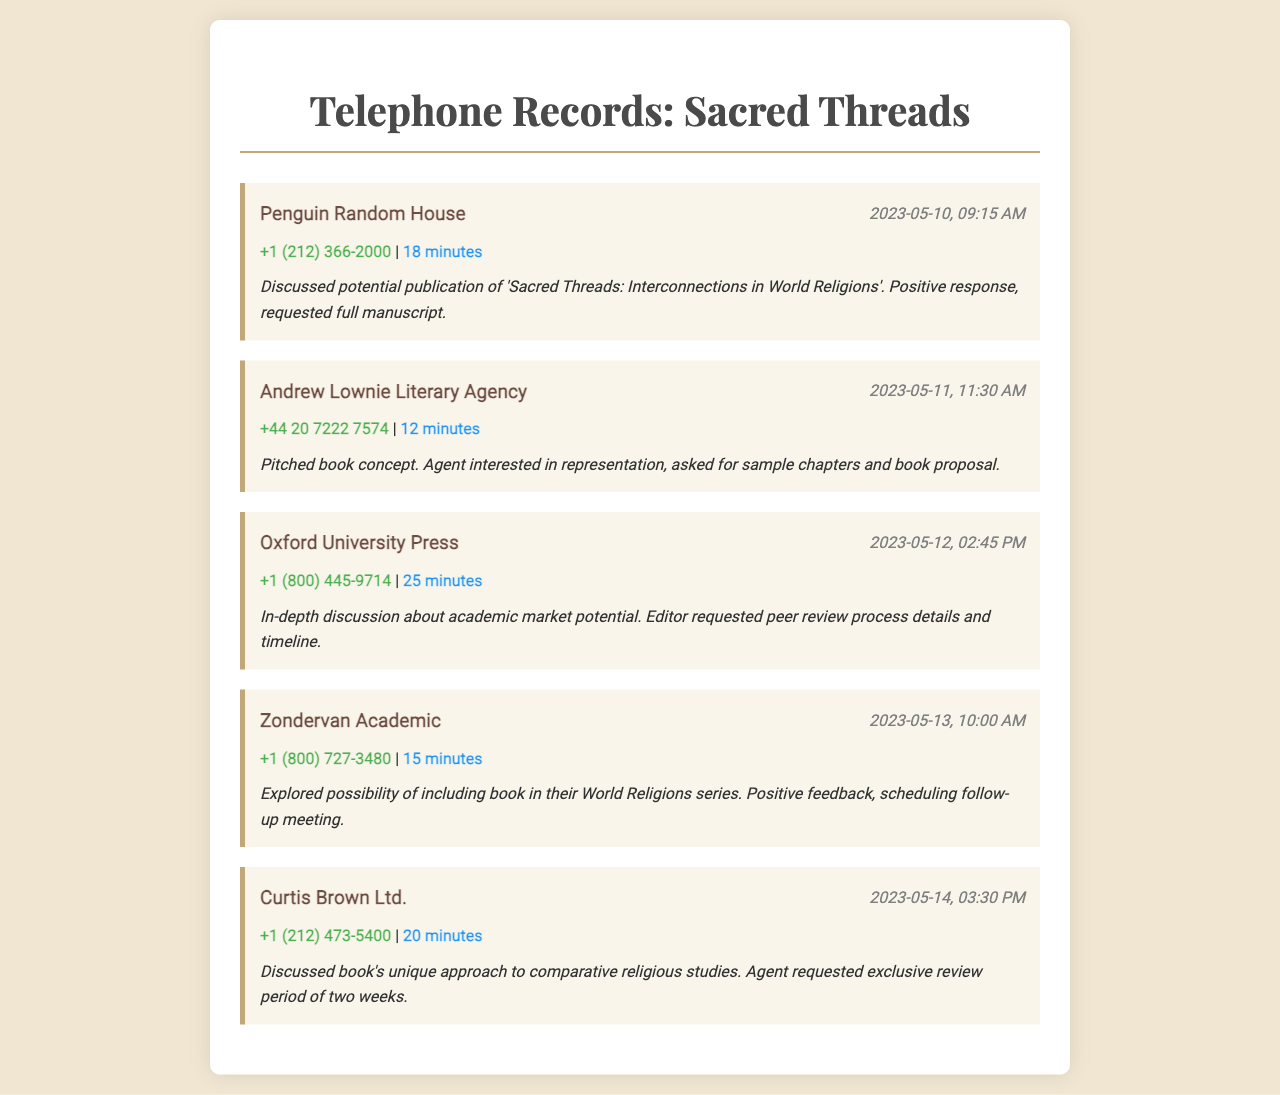What is the title of the book discussed? The title of the book is mentioned in the notes of the first record as 'Sacred Threads: Interconnections in World Religions'.
Answer: Sacred Threads: Interconnections in World Religions Who was contacted on May 12, 2023? The contact for May 12, 2023, was Oxford University Press as indicated in the date-time of the third record.
Answer: Oxford University Press How long was the call with Andrew Lownie Literary Agency? The duration of the call is specified in the second record as 12 minutes.
Answer: 12 minutes What information did the agent from Curtis Brown Ltd. request? The request made by the agent is documented in the notes, where they asked for an exclusive review period of two weeks.
Answer: Exclusive review period of two weeks Which agency expressed interest in representation? The agency that expressed interest in representation is mentioned in the notes of the second record, referring to Andrew Lownie Literary Agency.
Answer: Andrew Lownie Literary Agency What was discussed with Zondervan Academic? The conversation included the possibility of including the book in their World Religions series as per the notes of the fourth record.
Answer: Including the book in their World Religions series What was the focus of the discussion with Oxford University Press? The focus of the discussion was about academic market potential, as stated in the notes of the third record.
Answer: Academic market potential What was the feedback from the call on May 13, 2023? The feedback from that call was positive as noted in the fourth record.
Answer: Positive feedback 